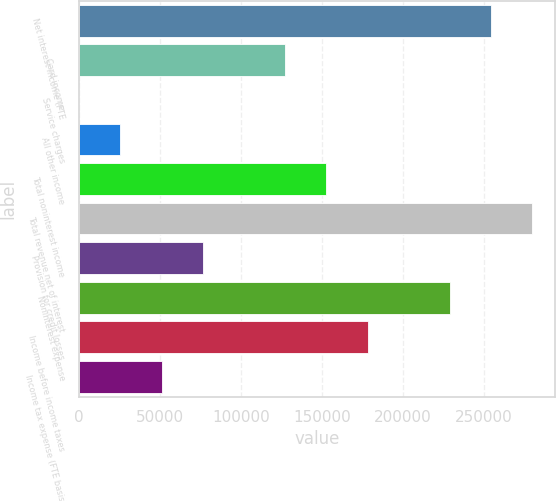<chart> <loc_0><loc_0><loc_500><loc_500><bar_chart><fcel>Net interest income (FTE<fcel>Card income<fcel>Service charges<fcel>All other income<fcel>Total noninterest income<fcel>Total revenue net of interest<fcel>Provision for credit losses<fcel>Noninterest expense<fcel>Income before income taxes<fcel>Income tax expense (FTE basis)<nl><fcel>254287<fcel>127144<fcel>1<fcel>25429.6<fcel>152573<fcel>279716<fcel>76286.8<fcel>228858<fcel>178001<fcel>50858.2<nl></chart> 